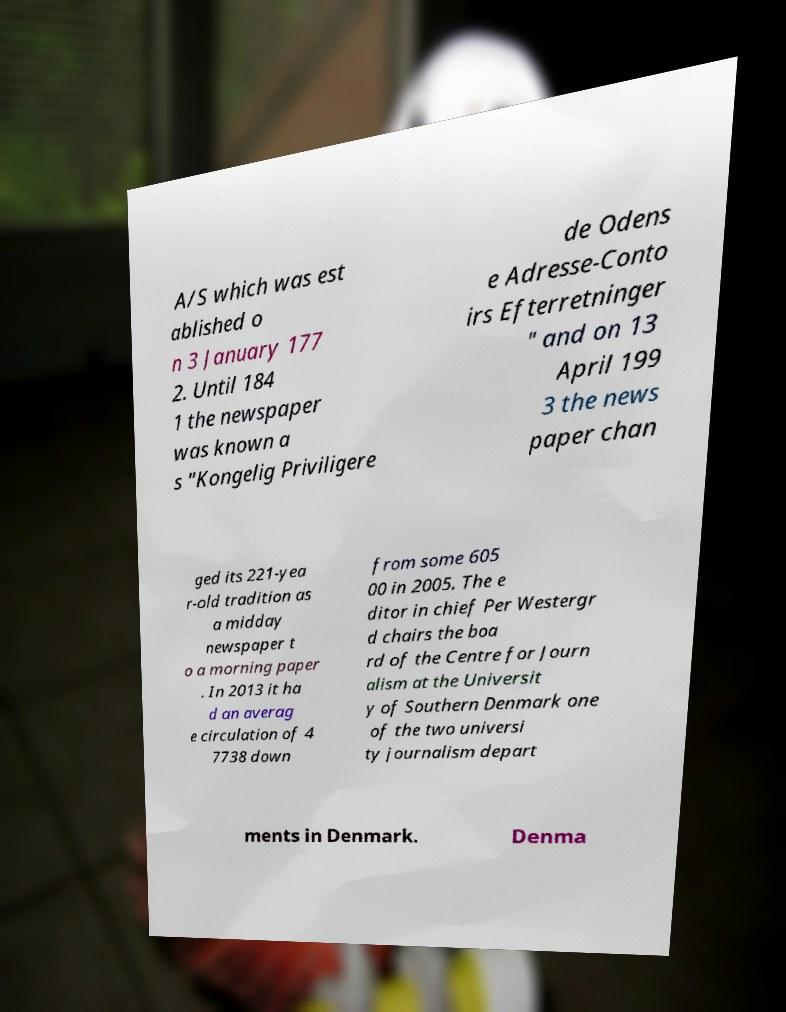Could you assist in decoding the text presented in this image and type it out clearly? A/S which was est ablished o n 3 January 177 2. Until 184 1 the newspaper was known a s "Kongelig Priviligere de Odens e Adresse-Conto irs Efterretninger " and on 13 April 199 3 the news paper chan ged its 221-yea r-old tradition as a midday newspaper t o a morning paper . In 2013 it ha d an averag e circulation of 4 7738 down from some 605 00 in 2005. The e ditor in chief Per Westergr d chairs the boa rd of the Centre for Journ alism at the Universit y of Southern Denmark one of the two universi ty journalism depart ments in Denmark. Denma 